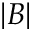<formula> <loc_0><loc_0><loc_500><loc_500>| B |</formula> 